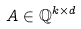Convert formula to latex. <formula><loc_0><loc_0><loc_500><loc_500>A \in \mathbb { Q } ^ { k \times d }</formula> 